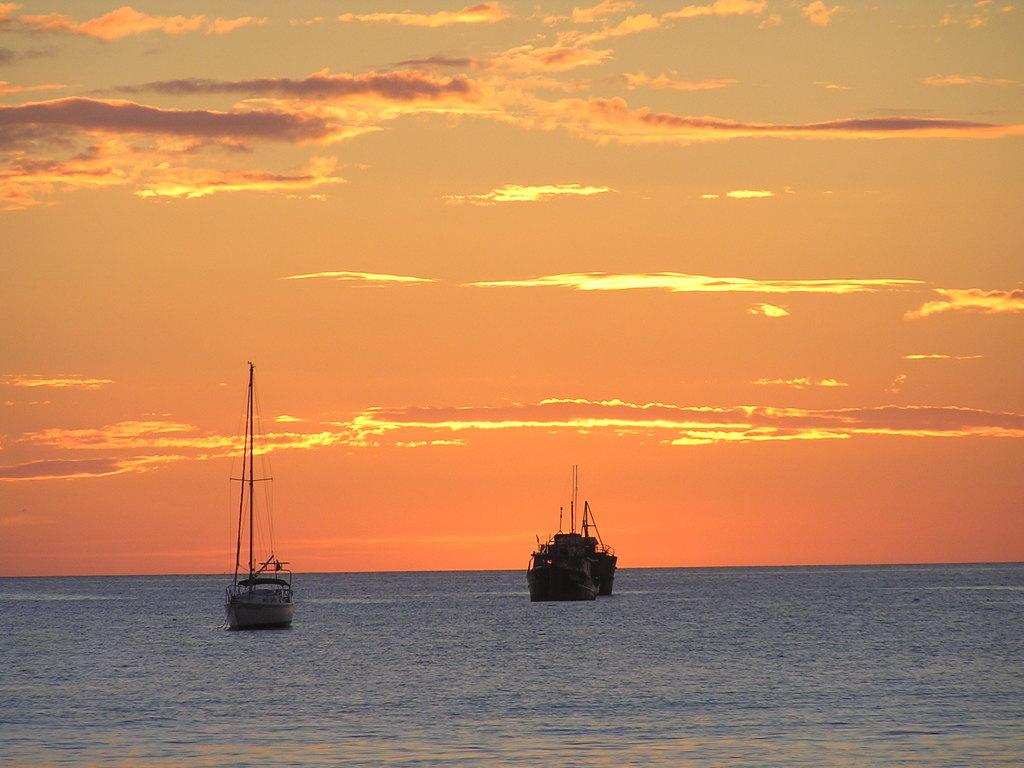What is the main subject of the image? The main subject of the image is ships. What is the ships' location in relation to the water? The ships are sailing on water. What color is the sky in the image? The sky is orange in color at the top of the image. What type of rock can be seen in the image? There is no rock present in the image; it features ships sailing on water with an orange sky. What kind of jewel is being used as a decoration on the ships? There is no mention of any jewels being used as decoration on the ships in the image. 